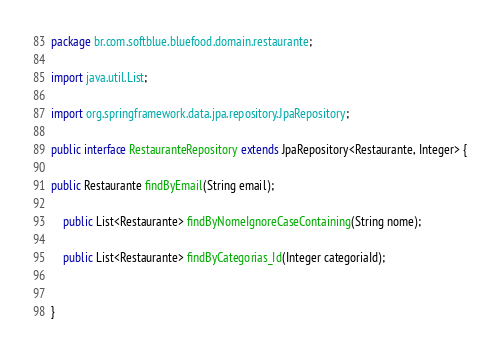<code> <loc_0><loc_0><loc_500><loc_500><_Java_>package br.com.softblue.bluefood.domain.restaurante;

import java.util.List;

import org.springframework.data.jpa.repository.JpaRepository;

public interface RestauranteRepository extends JpaRepository<Restaurante, Integer> {
	
public Restaurante findByEmail(String email);
	
	public List<Restaurante> findByNomeIgnoreCaseContaining(String nome);
	
	public List<Restaurante> findByCategorias_Id(Integer categoriaId);
	
	
}
</code> 